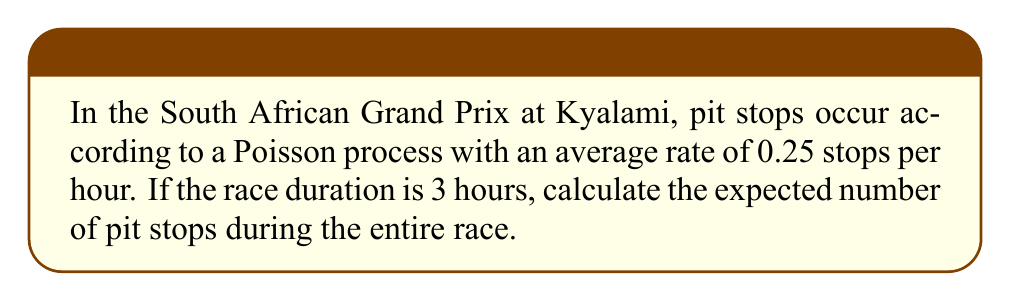Show me your answer to this math problem. To solve this problem, we'll use the properties of Poisson processes:

1. The number of events (pit stops) in a fixed time interval follows a Poisson distribution.
2. For a Poisson process, the expected number of events in a time interval is proportional to the length of the interval.

Let's define our variables:
- $\lambda$ = rate of pit stops per hour = 0.25
- $t$ = race duration in hours = 3

The expected number of events (pit stops) in a Poisson process is given by:

$$ E[N(t)] = \lambda t $$

Where:
- $E[N(t)]$ is the expected number of events in time $t$
- $\lambda$ is the rate of events per unit time
- $t$ is the time interval

Substituting our values:

$$ E[N(3)] = 0.25 \times 3 = 0.75 $$

Therefore, the expected number of pit stops during the 3-hour race is 0.75.
Answer: 0.75 pit stops 